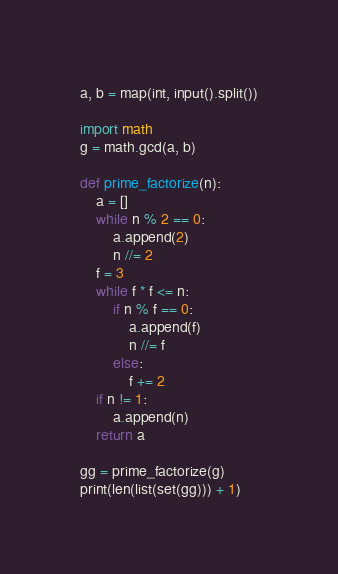<code> <loc_0><loc_0><loc_500><loc_500><_Python_>a, b = map(int, input().split())

import math
g = math.gcd(a, b)

def prime_factorize(n):
    a = []
    while n % 2 == 0:
        a.append(2)
        n //= 2
    f = 3
    while f * f <= n:
        if n % f == 0:
            a.append(f)
            n //= f
        else:
            f += 2
    if n != 1:
        a.append(n)
    return a

gg = prime_factorize(g)
print(len(list(set(gg))) + 1)
</code> 